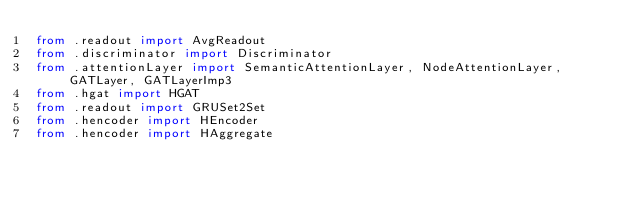Convert code to text. <code><loc_0><loc_0><loc_500><loc_500><_Python_>from .readout import AvgReadout
from .discriminator import Discriminator
from .attentionLayer import SemanticAttentionLayer, NodeAttentionLayer, GATLayer, GATLayerImp3
from .hgat import HGAT
from .readout import GRUSet2Set
from .hencoder import HEncoder
from .hencoder import HAggregate

</code> 